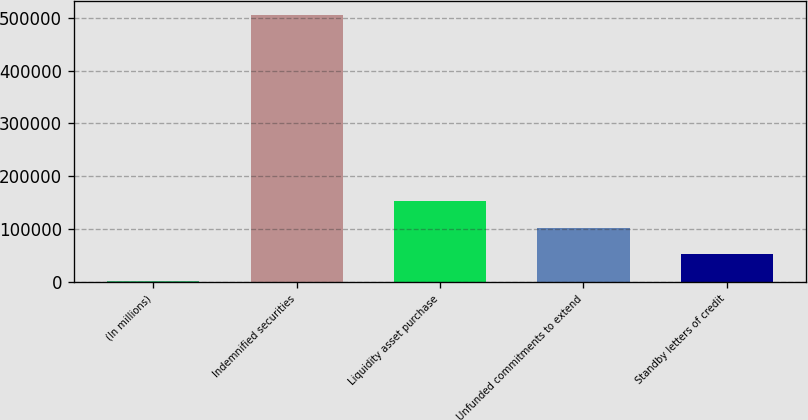<chart> <loc_0><loc_0><loc_500><loc_500><bar_chart><fcel>(In millions)<fcel>Indemnified securities<fcel>Liquidity asset purchase<fcel>Unfunded commitments to extend<fcel>Standby letters of credit<nl><fcel>2006<fcel>506032<fcel>153214<fcel>102811<fcel>52408.6<nl></chart> 